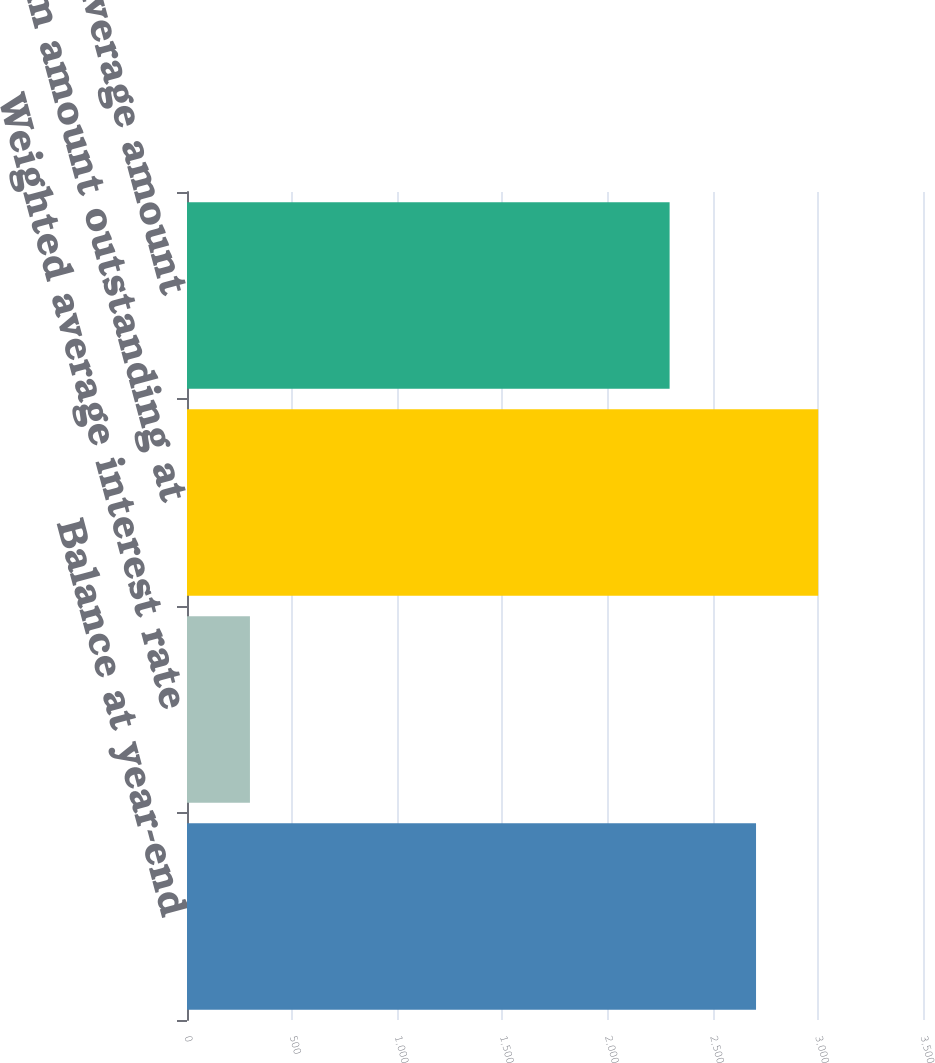Convert chart to OTSL. <chart><loc_0><loc_0><loc_500><loc_500><bar_chart><fcel>Balance at year-end<fcel>Weighted average interest rate<fcel>Maximum amount outstanding at<fcel>Average amount<nl><fcel>2706<fcel>299.29<fcel>3001.75<fcel>2295<nl></chart> 